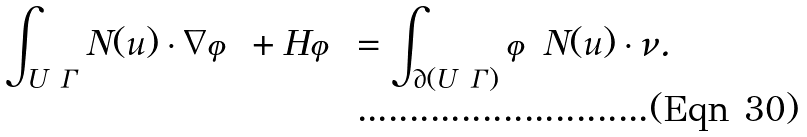<formula> <loc_0><loc_0><loc_500><loc_500>\int _ { U \ \Gamma } N ( u ) \cdot \nabla \varphi + H \varphi = \int _ { \partial ( U \ \Gamma ) } \varphi N ( u ) \cdot \nu .</formula> 